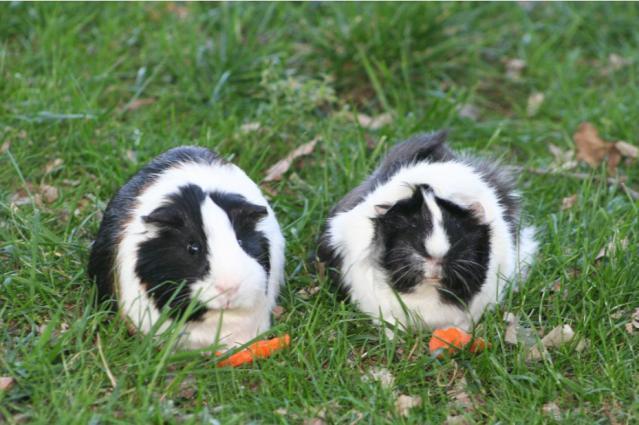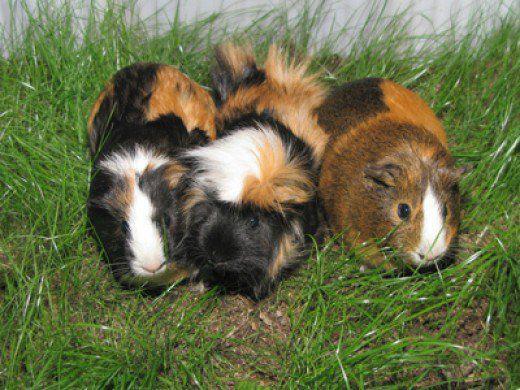The first image is the image on the left, the second image is the image on the right. Examine the images to the left and right. Is the description "There are 5 hamsters in the grass." accurate? Answer yes or no. Yes. The first image is the image on the left, the second image is the image on the right. Examine the images to the left and right. Is the description "Two gerbils are in a wire pen." accurate? Answer yes or no. No. 